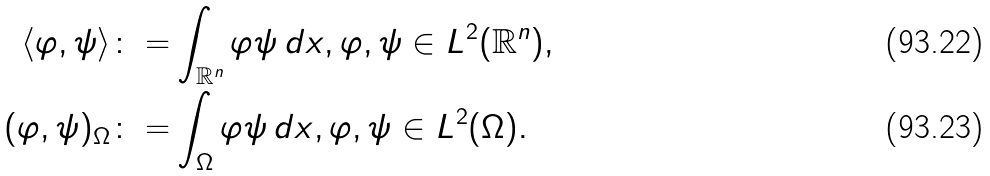<formula> <loc_0><loc_0><loc_500><loc_500>\langle \varphi , \psi \rangle \colon = & \int _ { \mathbb { R } ^ { n } } \varphi \psi \, d x , \varphi , \psi \in L ^ { 2 } ( \mathbb { R } ^ { n } ) , \\ ( \varphi , \psi ) _ { \Omega } \colon = & \int _ { \Omega } \varphi \psi \, d x , \varphi , \psi \in L ^ { 2 } ( \Omega ) .</formula> 